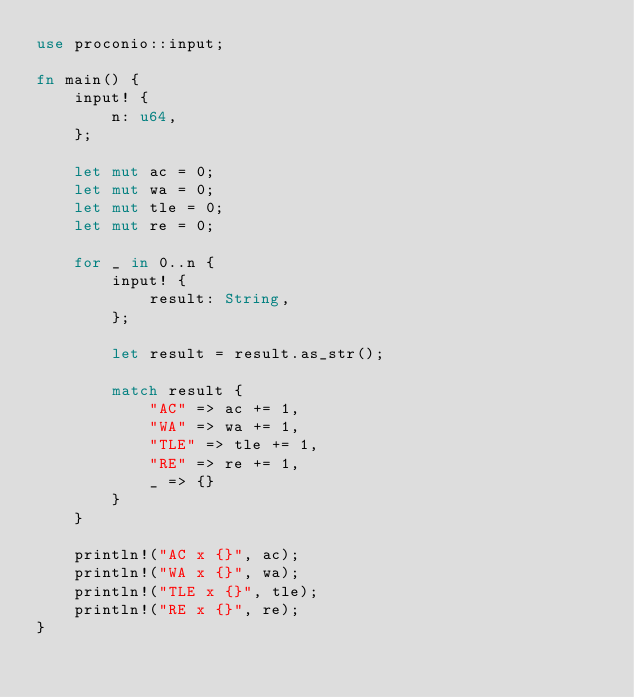<code> <loc_0><loc_0><loc_500><loc_500><_Rust_>use proconio::input;

fn main() {
    input! {
        n: u64,
    };

    let mut ac = 0;
    let mut wa = 0;
    let mut tle = 0;
    let mut re = 0;

    for _ in 0..n {
        input! {
            result: String,
        };

        let result = result.as_str();

        match result {
            "AC" => ac += 1,
            "WA" => wa += 1,
            "TLE" => tle += 1,
            "RE" => re += 1,
            _ => {}
        }
    }

    println!("AC x {}", ac);
    println!("WA x {}", wa);
    println!("TLE x {}", tle);
    println!("RE x {}", re);
}
</code> 